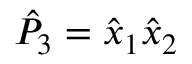Convert formula to latex. <formula><loc_0><loc_0><loc_500><loc_500>\hat { P } _ { 3 } = \hat { x } _ { 1 } \hat { x } _ { 2 }</formula> 